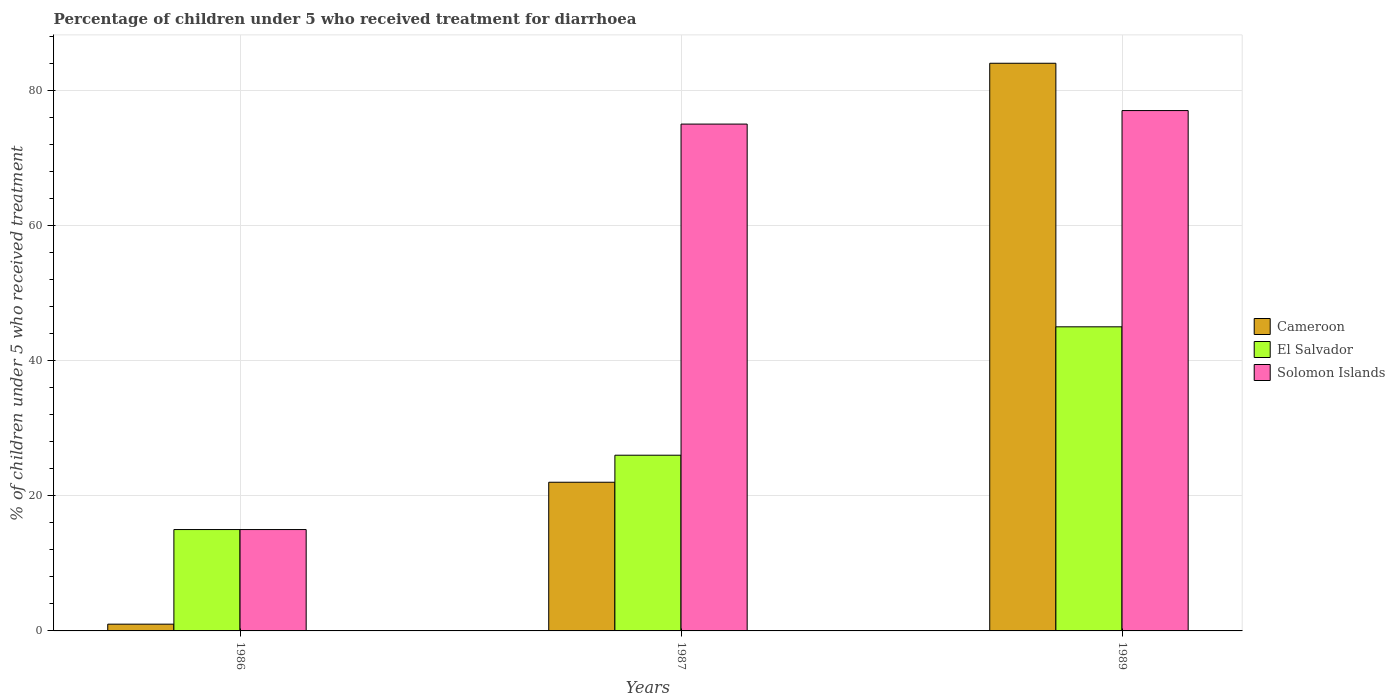How many different coloured bars are there?
Your answer should be very brief. 3. Are the number of bars per tick equal to the number of legend labels?
Your answer should be very brief. Yes. What is the label of the 3rd group of bars from the left?
Your answer should be compact. 1989. In how many cases, is the number of bars for a given year not equal to the number of legend labels?
Give a very brief answer. 0. What is the percentage of children who received treatment for diarrhoea  in Solomon Islands in 1987?
Offer a very short reply. 75. Across all years, what is the minimum percentage of children who received treatment for diarrhoea  in Cameroon?
Your answer should be very brief. 1. In which year was the percentage of children who received treatment for diarrhoea  in El Salvador minimum?
Provide a short and direct response. 1986. What is the total percentage of children who received treatment for diarrhoea  in Solomon Islands in the graph?
Make the answer very short. 167. What is the difference between the percentage of children who received treatment for diarrhoea  in El Salvador in 1986 and that in 1987?
Your answer should be very brief. -11. What is the difference between the percentage of children who received treatment for diarrhoea  in El Salvador in 1987 and the percentage of children who received treatment for diarrhoea  in Solomon Islands in 1989?
Your answer should be compact. -51. What is the average percentage of children who received treatment for diarrhoea  in Solomon Islands per year?
Make the answer very short. 55.67. In the year 1989, what is the difference between the percentage of children who received treatment for diarrhoea  in Cameroon and percentage of children who received treatment for diarrhoea  in El Salvador?
Your answer should be compact. 39. What is the ratio of the percentage of children who received treatment for diarrhoea  in Cameroon in 1987 to that in 1989?
Keep it short and to the point. 0.26. Is the difference between the percentage of children who received treatment for diarrhoea  in Cameroon in 1986 and 1989 greater than the difference between the percentage of children who received treatment for diarrhoea  in El Salvador in 1986 and 1989?
Make the answer very short. No. What is the difference between the highest and the second highest percentage of children who received treatment for diarrhoea  in Solomon Islands?
Offer a terse response. 2. Is the sum of the percentage of children who received treatment for diarrhoea  in El Salvador in 1986 and 1987 greater than the maximum percentage of children who received treatment for diarrhoea  in Cameroon across all years?
Keep it short and to the point. No. What does the 2nd bar from the left in 1989 represents?
Give a very brief answer. El Salvador. What does the 1st bar from the right in 1989 represents?
Make the answer very short. Solomon Islands. What is the difference between two consecutive major ticks on the Y-axis?
Offer a very short reply. 20. Are the values on the major ticks of Y-axis written in scientific E-notation?
Provide a short and direct response. No. Does the graph contain any zero values?
Ensure brevity in your answer.  No. Does the graph contain grids?
Provide a short and direct response. Yes. Where does the legend appear in the graph?
Provide a short and direct response. Center right. How many legend labels are there?
Provide a short and direct response. 3. What is the title of the graph?
Keep it short and to the point. Percentage of children under 5 who received treatment for diarrhoea. Does "East Asia (developing only)" appear as one of the legend labels in the graph?
Provide a succinct answer. No. What is the label or title of the Y-axis?
Give a very brief answer. % of children under 5 who received treatment. What is the % of children under 5 who received treatment in Cameroon in 1986?
Provide a short and direct response. 1. What is the % of children under 5 who received treatment in El Salvador in 1986?
Keep it short and to the point. 15. What is the % of children under 5 who received treatment of El Salvador in 1987?
Give a very brief answer. 26. What is the % of children under 5 who received treatment of Solomon Islands in 1989?
Keep it short and to the point. 77. Across all years, what is the maximum % of children under 5 who received treatment in Cameroon?
Provide a short and direct response. 84. Across all years, what is the maximum % of children under 5 who received treatment in El Salvador?
Your response must be concise. 45. Across all years, what is the minimum % of children under 5 who received treatment of Cameroon?
Make the answer very short. 1. Across all years, what is the minimum % of children under 5 who received treatment in Solomon Islands?
Offer a terse response. 15. What is the total % of children under 5 who received treatment in Cameroon in the graph?
Give a very brief answer. 107. What is the total % of children under 5 who received treatment of El Salvador in the graph?
Your answer should be compact. 86. What is the total % of children under 5 who received treatment of Solomon Islands in the graph?
Your answer should be very brief. 167. What is the difference between the % of children under 5 who received treatment in El Salvador in 1986 and that in 1987?
Ensure brevity in your answer.  -11. What is the difference between the % of children under 5 who received treatment in Solomon Islands in 1986 and that in 1987?
Keep it short and to the point. -60. What is the difference between the % of children under 5 who received treatment of Cameroon in 1986 and that in 1989?
Ensure brevity in your answer.  -83. What is the difference between the % of children under 5 who received treatment in El Salvador in 1986 and that in 1989?
Offer a very short reply. -30. What is the difference between the % of children under 5 who received treatment in Solomon Islands in 1986 and that in 1989?
Provide a succinct answer. -62. What is the difference between the % of children under 5 who received treatment in Cameroon in 1987 and that in 1989?
Provide a succinct answer. -62. What is the difference between the % of children under 5 who received treatment of El Salvador in 1987 and that in 1989?
Give a very brief answer. -19. What is the difference between the % of children under 5 who received treatment in Solomon Islands in 1987 and that in 1989?
Offer a very short reply. -2. What is the difference between the % of children under 5 who received treatment in Cameroon in 1986 and the % of children under 5 who received treatment in El Salvador in 1987?
Offer a terse response. -25. What is the difference between the % of children under 5 who received treatment of Cameroon in 1986 and the % of children under 5 who received treatment of Solomon Islands in 1987?
Offer a very short reply. -74. What is the difference between the % of children under 5 who received treatment of El Salvador in 1986 and the % of children under 5 who received treatment of Solomon Islands in 1987?
Provide a succinct answer. -60. What is the difference between the % of children under 5 who received treatment in Cameroon in 1986 and the % of children under 5 who received treatment in El Salvador in 1989?
Give a very brief answer. -44. What is the difference between the % of children under 5 who received treatment in Cameroon in 1986 and the % of children under 5 who received treatment in Solomon Islands in 1989?
Your answer should be very brief. -76. What is the difference between the % of children under 5 who received treatment in El Salvador in 1986 and the % of children under 5 who received treatment in Solomon Islands in 1989?
Provide a short and direct response. -62. What is the difference between the % of children under 5 who received treatment in Cameroon in 1987 and the % of children under 5 who received treatment in El Salvador in 1989?
Make the answer very short. -23. What is the difference between the % of children under 5 who received treatment in Cameroon in 1987 and the % of children under 5 who received treatment in Solomon Islands in 1989?
Provide a succinct answer. -55. What is the difference between the % of children under 5 who received treatment of El Salvador in 1987 and the % of children under 5 who received treatment of Solomon Islands in 1989?
Make the answer very short. -51. What is the average % of children under 5 who received treatment in Cameroon per year?
Provide a succinct answer. 35.67. What is the average % of children under 5 who received treatment in El Salvador per year?
Provide a short and direct response. 28.67. What is the average % of children under 5 who received treatment in Solomon Islands per year?
Your answer should be very brief. 55.67. In the year 1986, what is the difference between the % of children under 5 who received treatment of Cameroon and % of children under 5 who received treatment of El Salvador?
Ensure brevity in your answer.  -14. In the year 1986, what is the difference between the % of children under 5 who received treatment in El Salvador and % of children under 5 who received treatment in Solomon Islands?
Keep it short and to the point. 0. In the year 1987, what is the difference between the % of children under 5 who received treatment of Cameroon and % of children under 5 who received treatment of Solomon Islands?
Give a very brief answer. -53. In the year 1987, what is the difference between the % of children under 5 who received treatment in El Salvador and % of children under 5 who received treatment in Solomon Islands?
Your response must be concise. -49. In the year 1989, what is the difference between the % of children under 5 who received treatment in Cameroon and % of children under 5 who received treatment in Solomon Islands?
Your response must be concise. 7. In the year 1989, what is the difference between the % of children under 5 who received treatment of El Salvador and % of children under 5 who received treatment of Solomon Islands?
Give a very brief answer. -32. What is the ratio of the % of children under 5 who received treatment in Cameroon in 1986 to that in 1987?
Your response must be concise. 0.05. What is the ratio of the % of children under 5 who received treatment in El Salvador in 1986 to that in 1987?
Make the answer very short. 0.58. What is the ratio of the % of children under 5 who received treatment in Cameroon in 1986 to that in 1989?
Give a very brief answer. 0.01. What is the ratio of the % of children under 5 who received treatment in El Salvador in 1986 to that in 1989?
Provide a succinct answer. 0.33. What is the ratio of the % of children under 5 who received treatment in Solomon Islands in 1986 to that in 1989?
Ensure brevity in your answer.  0.19. What is the ratio of the % of children under 5 who received treatment in Cameroon in 1987 to that in 1989?
Your answer should be very brief. 0.26. What is the ratio of the % of children under 5 who received treatment of El Salvador in 1987 to that in 1989?
Offer a very short reply. 0.58. What is the difference between the highest and the second highest % of children under 5 who received treatment of Cameroon?
Offer a very short reply. 62. What is the difference between the highest and the second highest % of children under 5 who received treatment in El Salvador?
Give a very brief answer. 19. What is the difference between the highest and the second highest % of children under 5 who received treatment in Solomon Islands?
Offer a terse response. 2. What is the difference between the highest and the lowest % of children under 5 who received treatment of El Salvador?
Make the answer very short. 30. What is the difference between the highest and the lowest % of children under 5 who received treatment of Solomon Islands?
Make the answer very short. 62. 